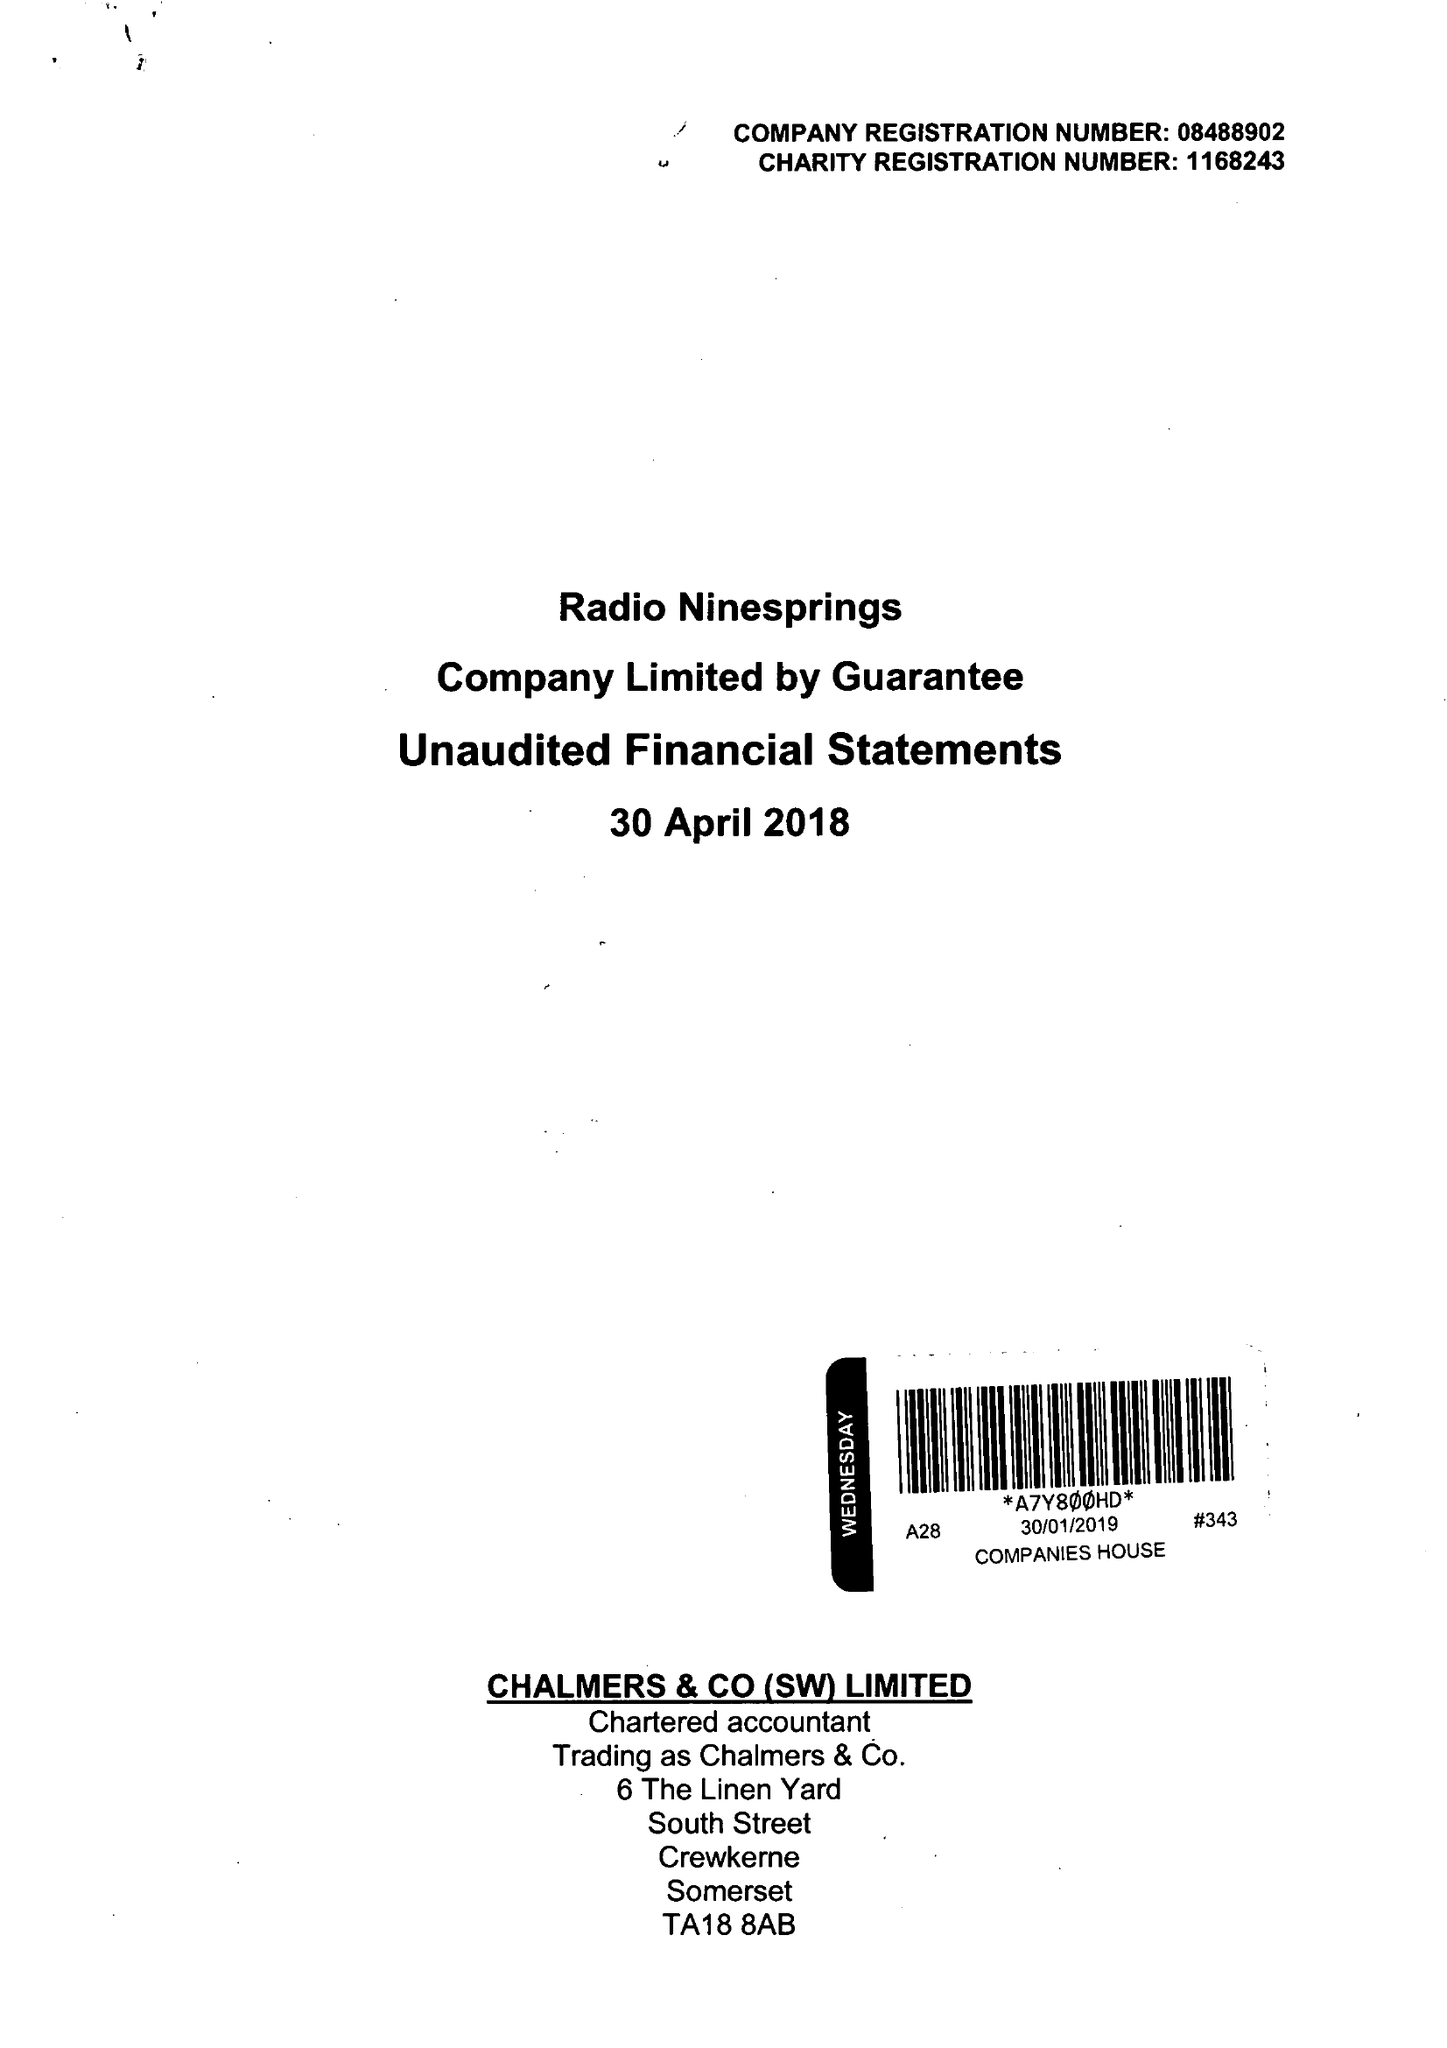What is the value for the charity_name?
Answer the question using a single word or phrase. Radio Ninesprings 